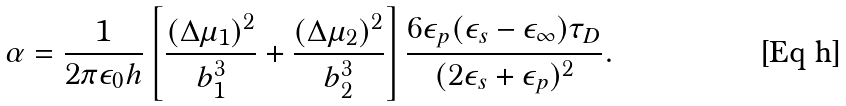<formula> <loc_0><loc_0><loc_500><loc_500>\alpha = \frac { 1 } { 2 \pi \epsilon _ { 0 } h } \left [ \frac { ( \Delta \mu _ { 1 } ) ^ { 2 } } { b _ { 1 } ^ { 3 } } + \frac { ( \Delta \mu _ { 2 } ) ^ { 2 } } { b _ { 2 } ^ { 3 } } \right ] \frac { 6 \epsilon _ { p } ( \epsilon _ { s } - \epsilon _ { \infty } ) \tau _ { D } } { ( 2 \epsilon _ { s } + \epsilon _ { p } ) ^ { 2 } } .</formula> 